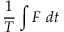Convert formula to latex. <formula><loc_0><loc_0><loc_500><loc_500>\frac { 1 } { T } \int F d t</formula> 